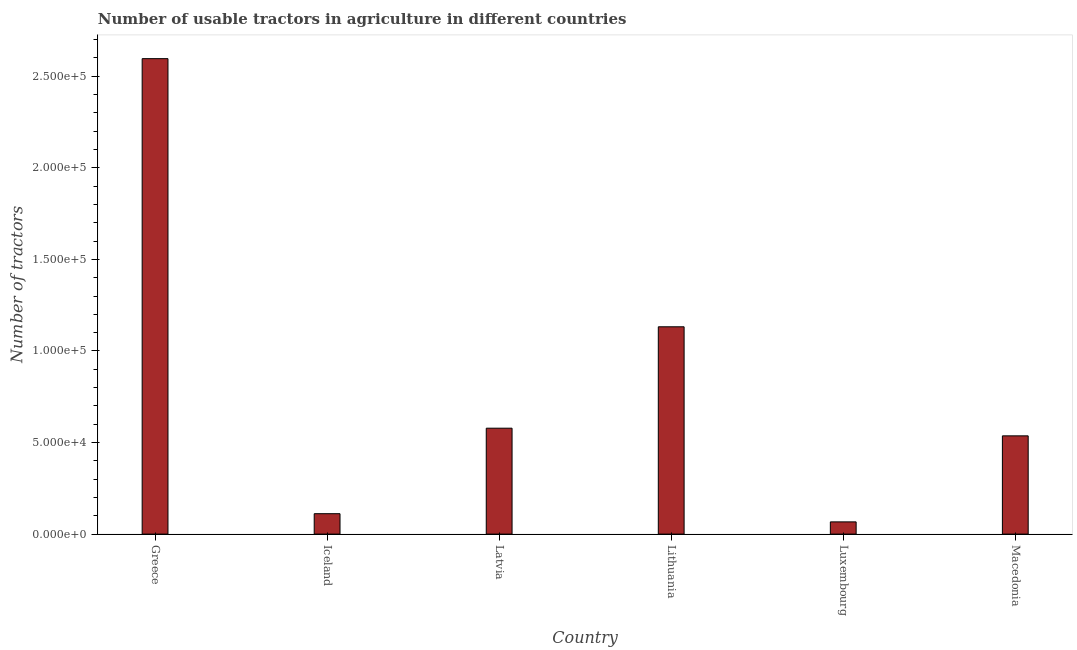What is the title of the graph?
Offer a very short reply. Number of usable tractors in agriculture in different countries. What is the label or title of the X-axis?
Provide a succinct answer. Country. What is the label or title of the Y-axis?
Offer a terse response. Number of tractors. What is the number of tractors in Latvia?
Keep it short and to the point. 5.78e+04. Across all countries, what is the maximum number of tractors?
Keep it short and to the point. 2.60e+05. Across all countries, what is the minimum number of tractors?
Your answer should be very brief. 6673. In which country was the number of tractors maximum?
Offer a very short reply. Greece. In which country was the number of tractors minimum?
Your response must be concise. Luxembourg. What is the sum of the number of tractors?
Offer a very short reply. 5.02e+05. What is the difference between the number of tractors in Greece and Luxembourg?
Provide a succinct answer. 2.53e+05. What is the average number of tractors per country?
Keep it short and to the point. 8.37e+04. What is the median number of tractors?
Your response must be concise. 5.57e+04. In how many countries, is the number of tractors greater than 180000 ?
Make the answer very short. 1. What is the ratio of the number of tractors in Greece to that in Luxembourg?
Give a very brief answer. 38.91. Is the number of tractors in Lithuania less than that in Luxembourg?
Offer a terse response. No. Is the difference between the number of tractors in Greece and Macedonia greater than the difference between any two countries?
Ensure brevity in your answer.  No. What is the difference between the highest and the second highest number of tractors?
Keep it short and to the point. 1.46e+05. What is the difference between the highest and the lowest number of tractors?
Provide a succinct answer. 2.53e+05. In how many countries, is the number of tractors greater than the average number of tractors taken over all countries?
Your response must be concise. 2. How many bars are there?
Ensure brevity in your answer.  6. Are all the bars in the graph horizontal?
Ensure brevity in your answer.  No. How many countries are there in the graph?
Offer a terse response. 6. What is the Number of tractors in Greece?
Provide a short and direct response. 2.60e+05. What is the Number of tractors in Iceland?
Your answer should be compact. 1.11e+04. What is the Number of tractors of Latvia?
Provide a short and direct response. 5.78e+04. What is the Number of tractors of Lithuania?
Offer a very short reply. 1.13e+05. What is the Number of tractors of Luxembourg?
Provide a short and direct response. 6673. What is the Number of tractors in Macedonia?
Provide a succinct answer. 5.36e+04. What is the difference between the Number of tractors in Greece and Iceland?
Keep it short and to the point. 2.48e+05. What is the difference between the Number of tractors in Greece and Latvia?
Your answer should be very brief. 2.02e+05. What is the difference between the Number of tractors in Greece and Lithuania?
Give a very brief answer. 1.46e+05. What is the difference between the Number of tractors in Greece and Luxembourg?
Make the answer very short. 2.53e+05. What is the difference between the Number of tractors in Greece and Macedonia?
Keep it short and to the point. 2.06e+05. What is the difference between the Number of tractors in Iceland and Latvia?
Give a very brief answer. -4.67e+04. What is the difference between the Number of tractors in Iceland and Lithuania?
Provide a short and direct response. -1.02e+05. What is the difference between the Number of tractors in Iceland and Luxembourg?
Offer a terse response. 4471. What is the difference between the Number of tractors in Iceland and Macedonia?
Your response must be concise. -4.25e+04. What is the difference between the Number of tractors in Latvia and Lithuania?
Provide a succinct answer. -5.54e+04. What is the difference between the Number of tractors in Latvia and Luxembourg?
Your answer should be compact. 5.12e+04. What is the difference between the Number of tractors in Latvia and Macedonia?
Your answer should be very brief. 4180. What is the difference between the Number of tractors in Lithuania and Luxembourg?
Provide a short and direct response. 1.07e+05. What is the difference between the Number of tractors in Lithuania and Macedonia?
Provide a short and direct response. 5.96e+04. What is the difference between the Number of tractors in Luxembourg and Macedonia?
Provide a succinct answer. -4.70e+04. What is the ratio of the Number of tractors in Greece to that in Iceland?
Offer a terse response. 23.3. What is the ratio of the Number of tractors in Greece to that in Latvia?
Make the answer very short. 4.49. What is the ratio of the Number of tractors in Greece to that in Lithuania?
Offer a very short reply. 2.29. What is the ratio of the Number of tractors in Greece to that in Luxembourg?
Give a very brief answer. 38.91. What is the ratio of the Number of tractors in Greece to that in Macedonia?
Give a very brief answer. 4.84. What is the ratio of the Number of tractors in Iceland to that in Latvia?
Your response must be concise. 0.19. What is the ratio of the Number of tractors in Iceland to that in Lithuania?
Provide a short and direct response. 0.1. What is the ratio of the Number of tractors in Iceland to that in Luxembourg?
Your response must be concise. 1.67. What is the ratio of the Number of tractors in Iceland to that in Macedonia?
Ensure brevity in your answer.  0.21. What is the ratio of the Number of tractors in Latvia to that in Lithuania?
Your answer should be compact. 0.51. What is the ratio of the Number of tractors in Latvia to that in Luxembourg?
Offer a very short reply. 8.67. What is the ratio of the Number of tractors in Latvia to that in Macedonia?
Make the answer very short. 1.08. What is the ratio of the Number of tractors in Lithuania to that in Luxembourg?
Ensure brevity in your answer.  16.96. What is the ratio of the Number of tractors in Lithuania to that in Macedonia?
Ensure brevity in your answer.  2.11. What is the ratio of the Number of tractors in Luxembourg to that in Macedonia?
Ensure brevity in your answer.  0.12. 